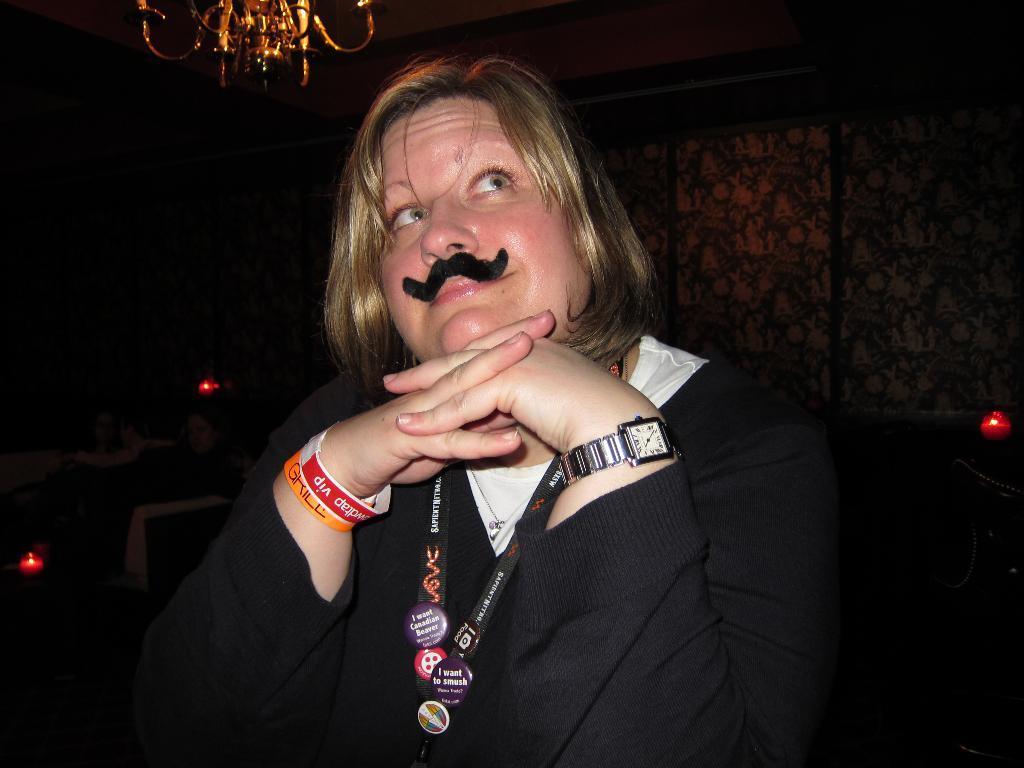In one or two sentences, can you explain what this image depicts? In this image we can see a person sitting on the chair. In the background we can see walls and a chandelier. 